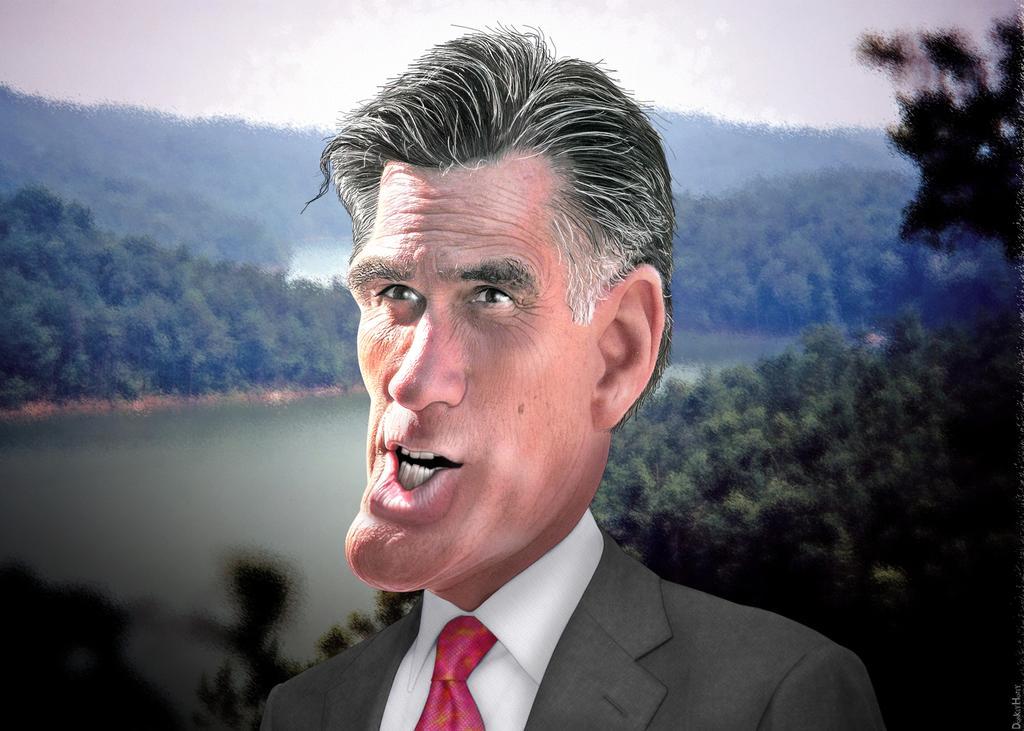Can you describe this image briefly? In this picture there is a person wearing suit and there are trees and water in the background. 